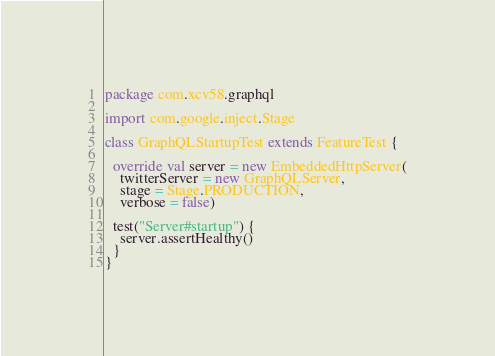<code> <loc_0><loc_0><loc_500><loc_500><_Scala_>package com.xcv58.graphql

import com.google.inject.Stage

class GraphQLStartupTest extends FeatureTest {

  override val server = new EmbeddedHttpServer(
    twitterServer = new GraphQLServer,
    stage = Stage.PRODUCTION,
    verbose = false)

  test("Server#startup") {
    server.assertHealthy()
  }
}
</code> 